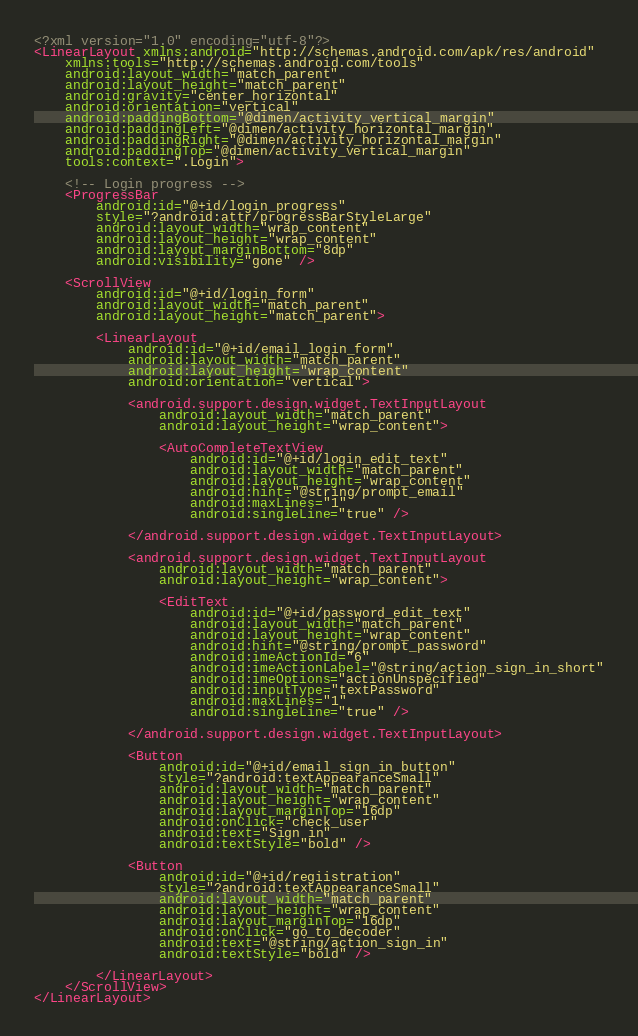<code> <loc_0><loc_0><loc_500><loc_500><_XML_><?xml version="1.0" encoding="utf-8"?>
<LinearLayout xmlns:android="http://schemas.android.com/apk/res/android"
    xmlns:tools="http://schemas.android.com/tools"
    android:layout_width="match_parent"
    android:layout_height="match_parent"
    android:gravity="center_horizontal"
    android:orientation="vertical"
    android:paddingBottom="@dimen/activity_vertical_margin"
    android:paddingLeft="@dimen/activity_horizontal_margin"
    android:paddingRight="@dimen/activity_horizontal_margin"
    android:paddingTop="@dimen/activity_vertical_margin"
    tools:context=".Login">

    <!-- Login progress -->
    <ProgressBar
        android:id="@+id/login_progress"
        style="?android:attr/progressBarStyleLarge"
        android:layout_width="wrap_content"
        android:layout_height="wrap_content"
        android:layout_marginBottom="8dp"
        android:visibility="gone" />

    <ScrollView
        android:id="@+id/login_form"
        android:layout_width="match_parent"
        android:layout_height="match_parent">

        <LinearLayout
            android:id="@+id/email_login_form"
            android:layout_width="match_parent"
            android:layout_height="wrap_content"
            android:orientation="vertical">

            <android.support.design.widget.TextInputLayout
                android:layout_width="match_parent"
                android:layout_height="wrap_content">

                <AutoCompleteTextView
                    android:id="@+id/login_edit_text"
                    android:layout_width="match_parent"
                    android:layout_height="wrap_content"
                    android:hint="@string/prompt_email"
                    android:maxLines="1"
                    android:singleLine="true" />

            </android.support.design.widget.TextInputLayout>

            <android.support.design.widget.TextInputLayout
                android:layout_width="match_parent"
                android:layout_height="wrap_content">

                <EditText
                    android:id="@+id/password_edit_text"
                    android:layout_width="match_parent"
                    android:layout_height="wrap_content"
                    android:hint="@string/prompt_password"
                    android:imeActionId="6"
                    android:imeActionLabel="@string/action_sign_in_short"
                    android:imeOptions="actionUnspecified"
                    android:inputType="textPassword"
                    android:maxLines="1"
                    android:singleLine="true" />

            </android.support.design.widget.TextInputLayout>

            <Button
                android:id="@+id/email_sign_in_button"
                style="?android:textAppearanceSmall"
                android:layout_width="match_parent"
                android:layout_height="wrap_content"
                android:layout_marginTop="16dp"
                android:onClick="check_user"
                android:text="Sign in"
                android:textStyle="bold" />

            <Button
                android:id="@+id/regiistration"
                style="?android:textAppearanceSmall"
                android:layout_width="match_parent"
                android:layout_height="wrap_content"
                android:layout_marginTop="16dp"
                android:onClick="go_to_decoder"
                android:text="@string/action_sign_in"
                android:textStyle="bold" />

        </LinearLayout>
    </ScrollView>
</LinearLayout></code> 